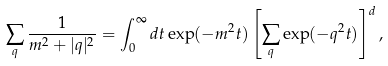<formula> <loc_0><loc_0><loc_500><loc_500>\sum _ { q } \frac { 1 } { m ^ { 2 } + | q | ^ { 2 } } = \int _ { 0 } ^ { \infty } d t \exp ( - m ^ { 2 } t ) \left [ \sum _ { q } \exp ( - q ^ { 2 } t ) \right ] ^ { d } ,</formula> 